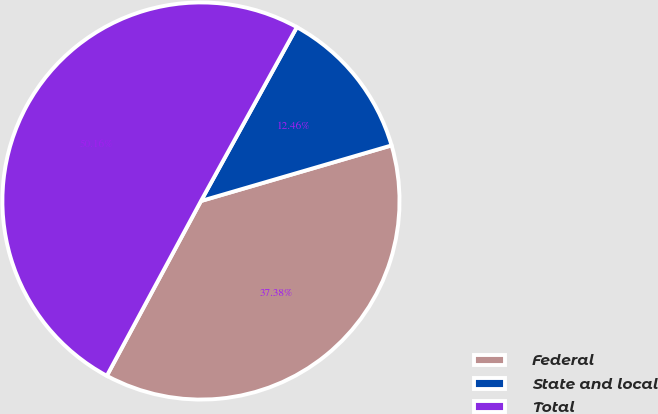<chart> <loc_0><loc_0><loc_500><loc_500><pie_chart><fcel>Federal<fcel>State and local<fcel>Total<nl><fcel>37.38%<fcel>12.46%<fcel>50.16%<nl></chart> 